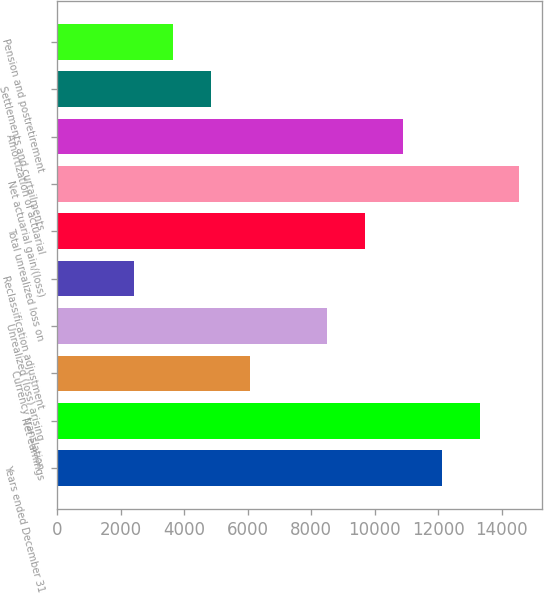Convert chart to OTSL. <chart><loc_0><loc_0><loc_500><loc_500><bar_chart><fcel>Years ended December 31<fcel>Net earnings<fcel>Currency translation<fcel>Unrealized (loss) arising<fcel>Reclassification adjustment<fcel>Total unrealized loss on<fcel>Net actuarial gain/(loss)<fcel>Amortization of actuarial<fcel>Settlements and curtailments<fcel>Pension and postretirement<nl><fcel>12116<fcel>13326.7<fcel>6062.5<fcel>8483.9<fcel>2430.4<fcel>9694.6<fcel>14537.4<fcel>10905.3<fcel>4851.8<fcel>3641.1<nl></chart> 